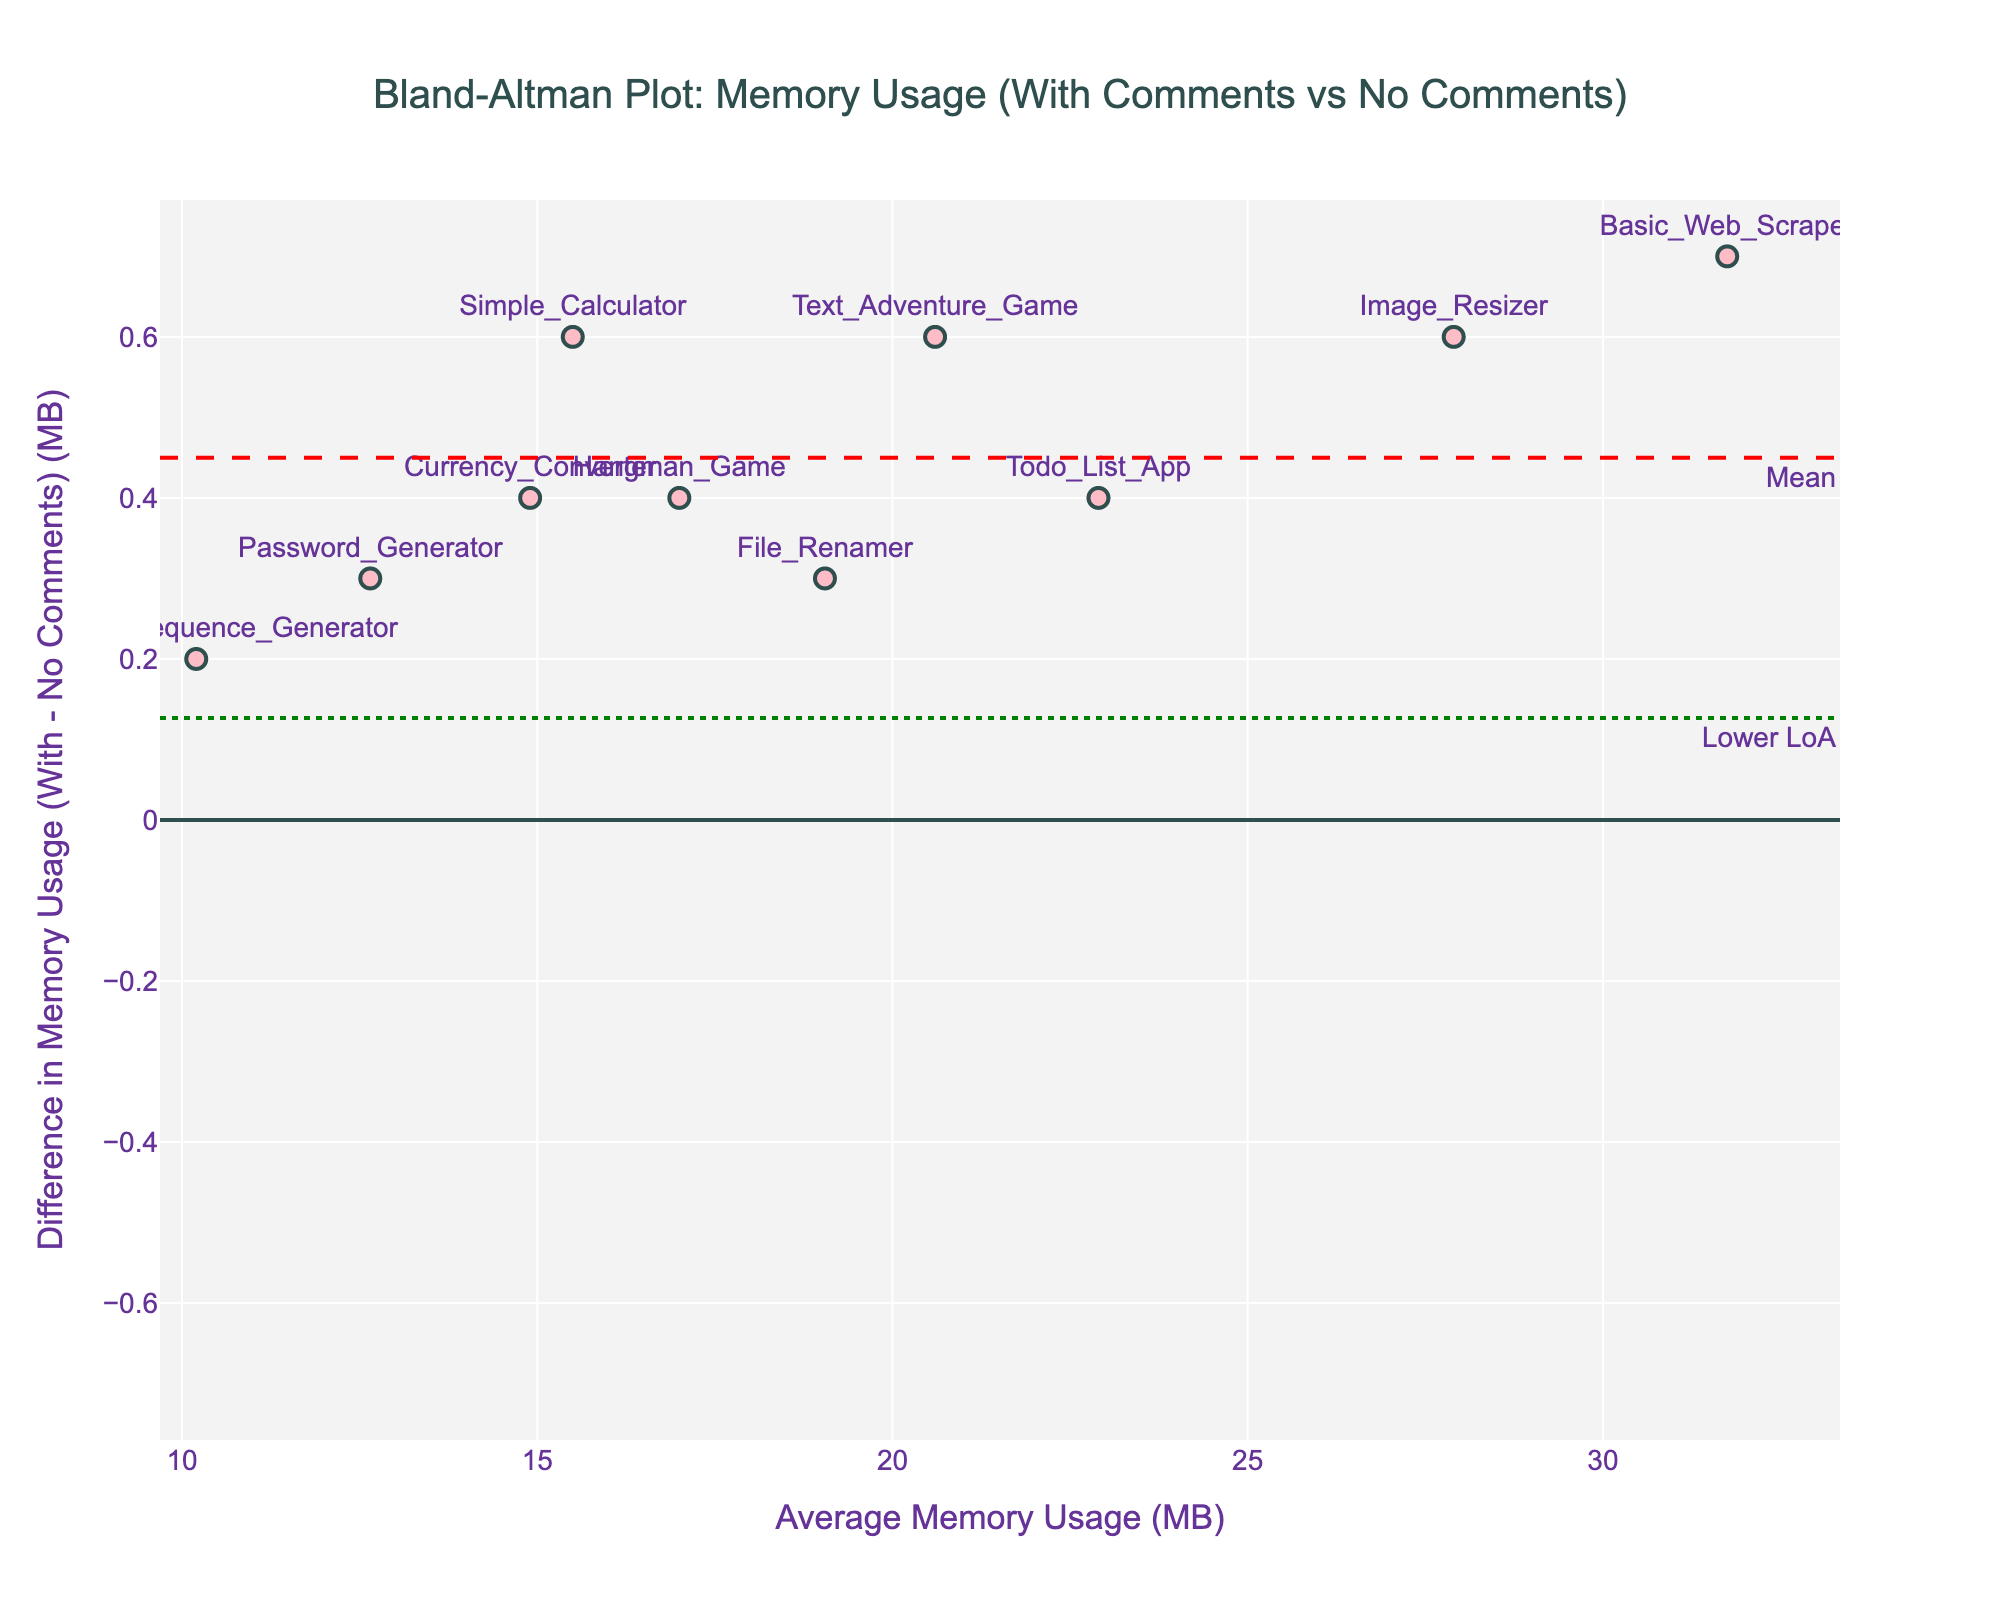What is the title of the plot? The title of the plot is written at the top of the figure. It reads: "Bland-Altman Plot: Memory Usage (With Comments vs No Comments)"
Answer: Bland-Altman Plot: Memory Usage (With Comments vs No Comments) What is the x-axis label? The x-axis label, located under the horizontal axis, reads: "Average Memory Usage (MB)"
Answer: Average Memory Usage (MB) What does the y-axis represent in this Bland-Altman plot? The y-axis represents the difference in memory usage (in MB) between programs with comments and without comments.
Answer: Difference in Memory Usage (With - No Comments) (MB) How many data points are there in the plot? There are 10 data points in the figure, each corresponding to a different program.
Answer: 10 Which program has the highest positive difference in memory usage? By inspecting the figure and the data labels near the points, the "Basic_Web_Scraper" has the highest positive difference in memory usage.
Answer: Basic_Web_Scraper What color are the data point markers? The data point markers are pink, as indicated by their appearance in the figure.
Answer: Pink What is the mean difference line value? The mean difference line value is shown with a red dashed line on the plot. It represents the mean difference of memory usage between programs with and without comments, which is 0.5 MB (approximately).
Answer: ~0.5 MB What are the upper and lower limits of agreement? The upper and lower limits of agreement are shown with green dotted lines on the plot. They are approximately 0.867 MB and 0.133 MB, respectively.
Answer: Upper ~0.867 MB, Lower ~0.133 MB Which program has the closest memory usage with and without comments? The "Fibonacci_Sequence_Generator" program has the smallest difference in memory usage between with and without comments, as observed at the closest point to the y=0 line in the plot.
Answer: Fibonacci_Sequence_Generator Are any data points outside the limits of agreement? By visually inspecting the data points and the limits of agreement lines, no data points are outside the green dotted lines marking the limits of agreement.
Answer: No 